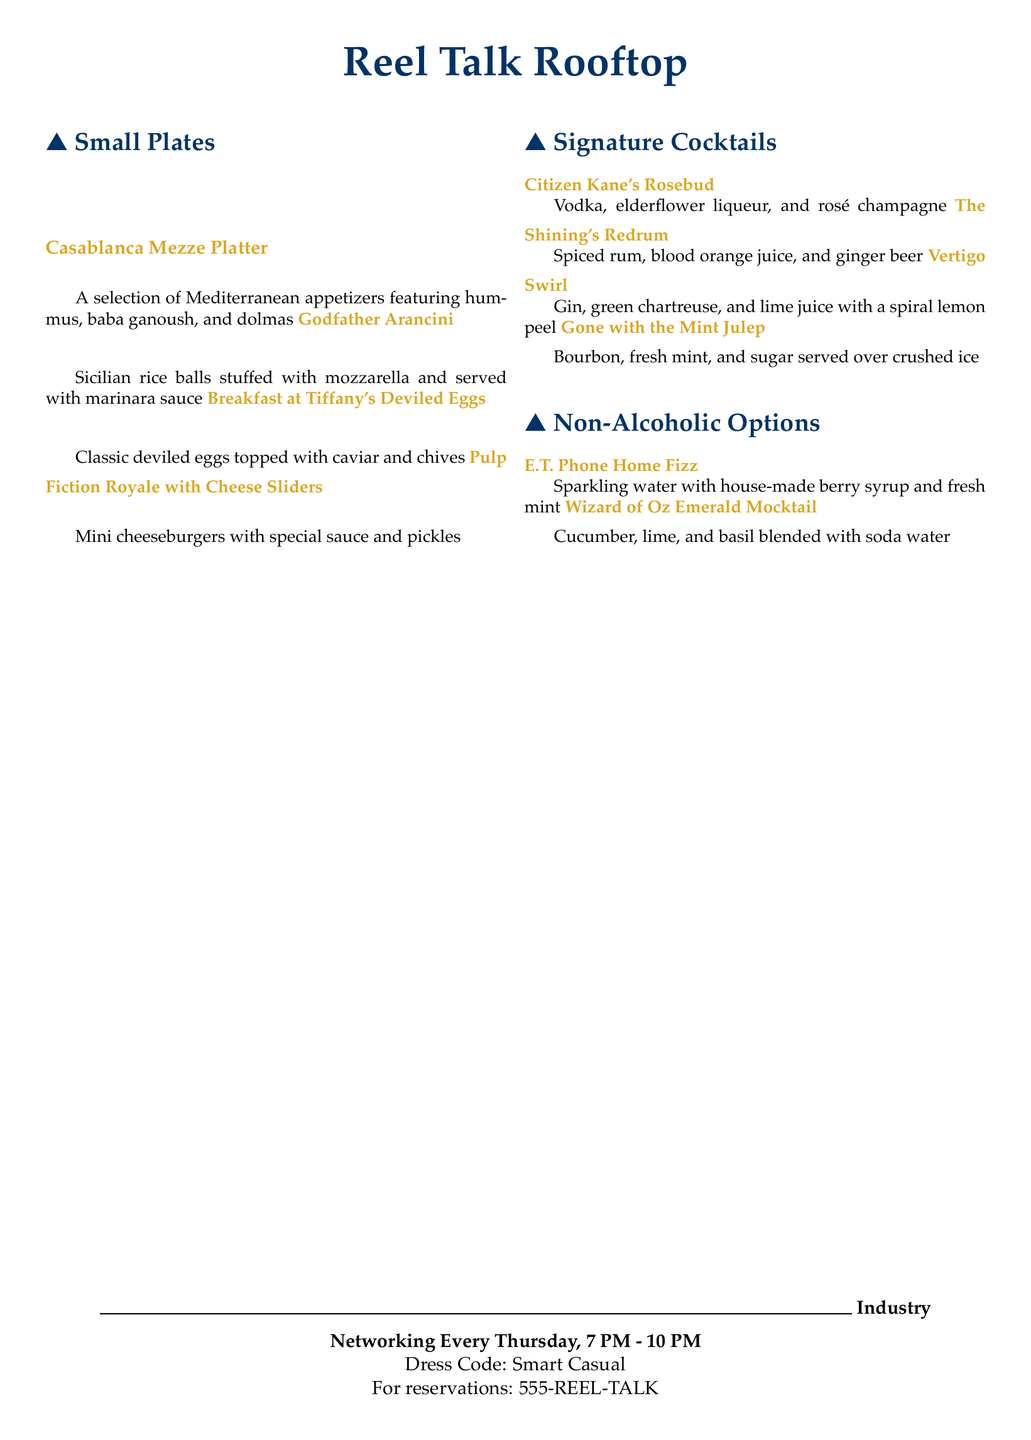What is the name of the rooftop bar? The name of the rooftop bar is clearly stated at the top of the menu.
Answer: Reel Talk Rooftop What are the operating hours for industry networking events? The operating hours for industry networking events are given towards the bottom of the document.
Answer: Every Thursday, 7 PM - 10 PM What is in the Casablanca Mezze Platter? The items in the Casablanca Mezze Platter are listed under Small Plates.
Answer: Hummus, baba ganoush, and dolmas Which cocktail is made with spiced rum? The cocktail options include a specific drink listed with spiced rum in the title.
Answer: The Shining's Redrum What dress code is mentioned for the events? The dress code is explicitly stated in the document under the event details.
Answer: Smart Casual How many small plates are listed in total? The number of small plates can be counted from the Small Plates section of the menu.
Answer: Four What is unique about the Wizard of Oz Emerald Mocktail? The ingredients for the Wizard of Oz Emerald Mocktail are provided in the Non-Alcoholic Options section.
Answer: Cucumber, lime, and basil Which drink is associated with vodka? The drink associated with vodka is mentioned among the Signature Cocktails.
Answer: Citizen Kane's Rosebud Are there any vegetarian options available? The Small Plates section includes items that can typically be classified as vegetarian.
Answer: Yes 